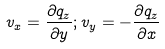Convert formula to latex. <formula><loc_0><loc_0><loc_500><loc_500>v _ { x } = \frac { \partial q _ { z } } { \partial y } ; v _ { y } = - \frac { \partial q _ { z } } { \partial x }</formula> 